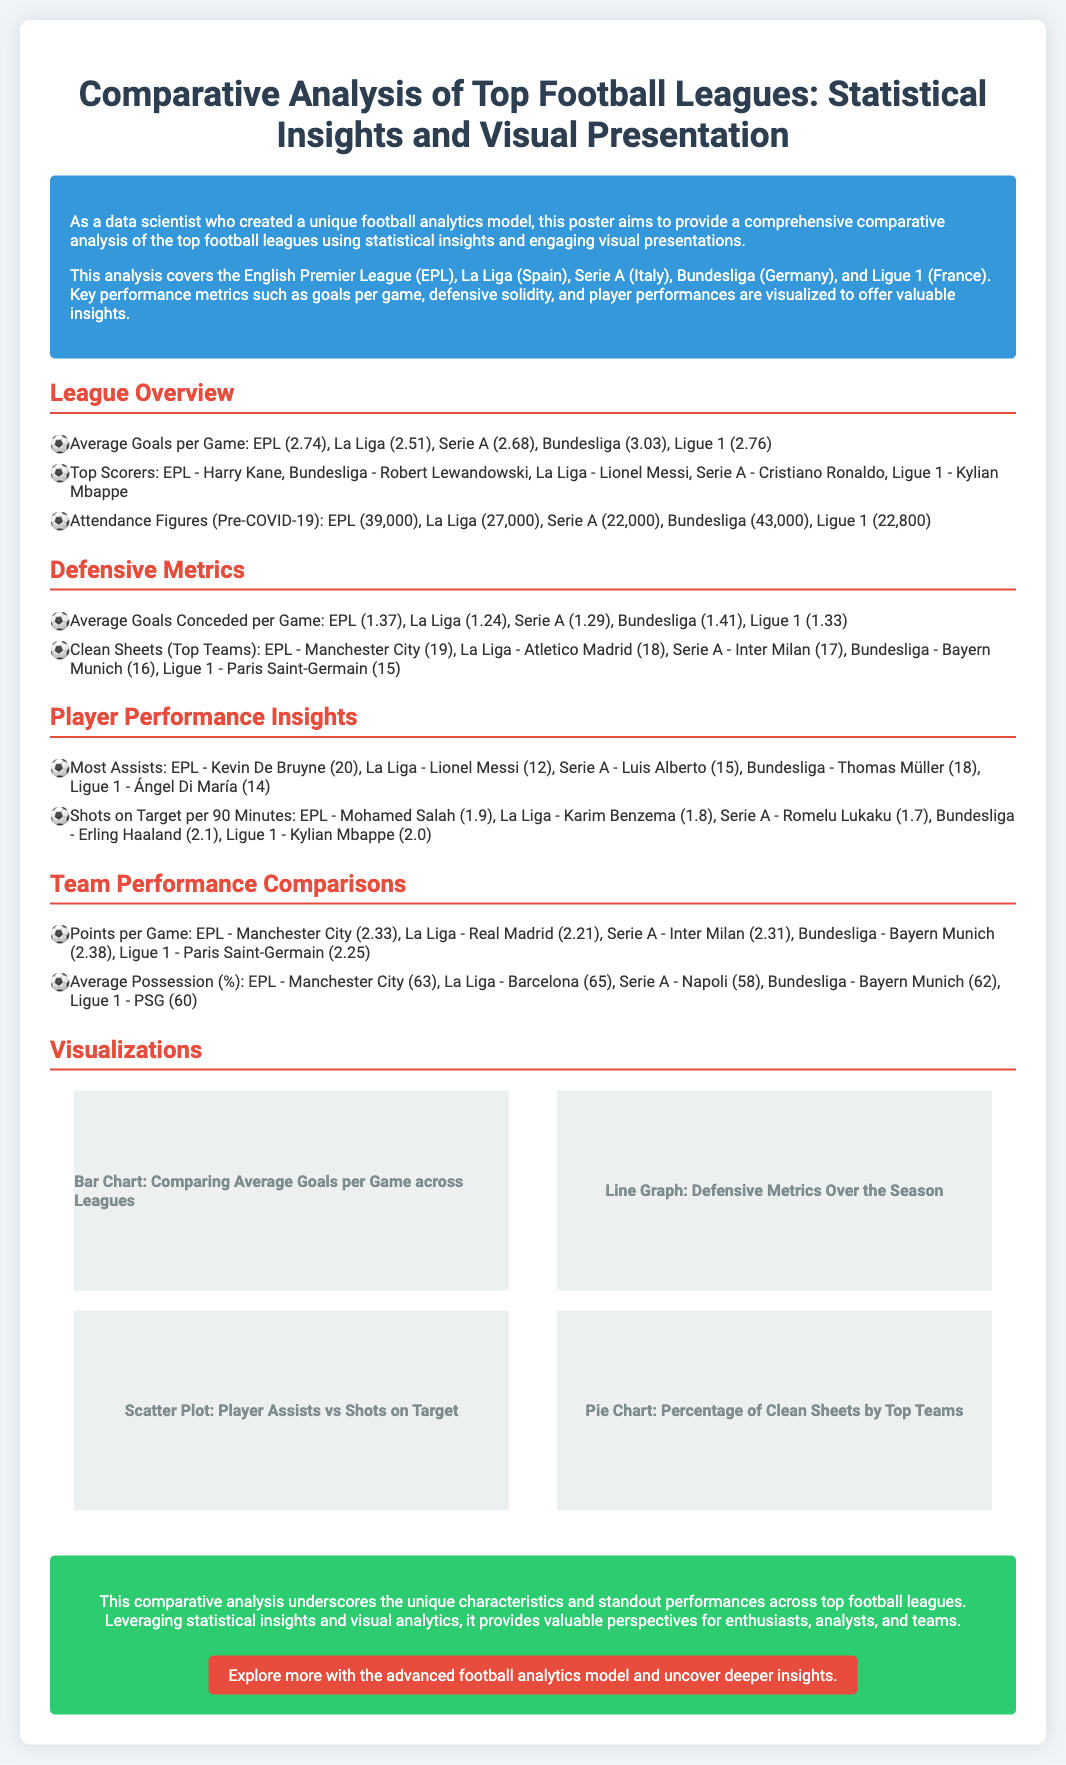What is the average goals per game in the Bundesliga? The average goals per game in the Bundesliga is 3.03, as stated in the league overview section.
Answer: 3.03 Who is the top scorer in Serie A? The top scorer in Serie A is Cristiano Ronaldo, mentioned in the league overview section.
Answer: Cristiano Ronaldo How many clean sheets did Manchester City achieve in the EPL? Manchester City achieved 19 clean sheets in the EPL, as highlighted in the defensive metrics section.
Answer: 19 Which league has the highest average attendance figures pre-COVID-19? The Bundesliga has the highest average attendance figures, listed as 43,000 in the league overview section.
Answer: 43,000 What percentage of clean sheets did Atletico Madrid achieve in La Liga? Atletico Madrid achieved 18 clean sheets in La Liga, according to the defensive metrics section.
Answer: 18 Which player had the most assists in the EPL? Kevin De Bruyne had the most assists in the EPL with 20, as mentioned in the player performance insights section.
Answer: Kevin De Bruyne What is the average possession percentage of Barcelona in La Liga? Barcelona has an average possession percentage of 65%, as stated in the team performance comparisons section.
Answer: 65 Which visualization compares average goals per game across leagues? The bar chart visualizes the comparison of average goals per game across leagues, as noted in the visualizations section.
Answer: Bar Chart What are the standout performances highlighted in the conclusion? The conclusion emphasizes unique characteristics and standout performances across top football leagues.
Answer: Unique characteristics and standout performances 